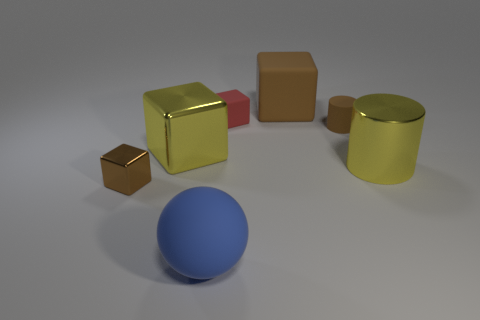There is a small block that is left of the large yellow shiny object that is left of the matte ball; what is its color? The color of the small block that is positioned to the left of the large yellow shiny object, which in turn is located to the left of the matte ball, appears to be brown. 